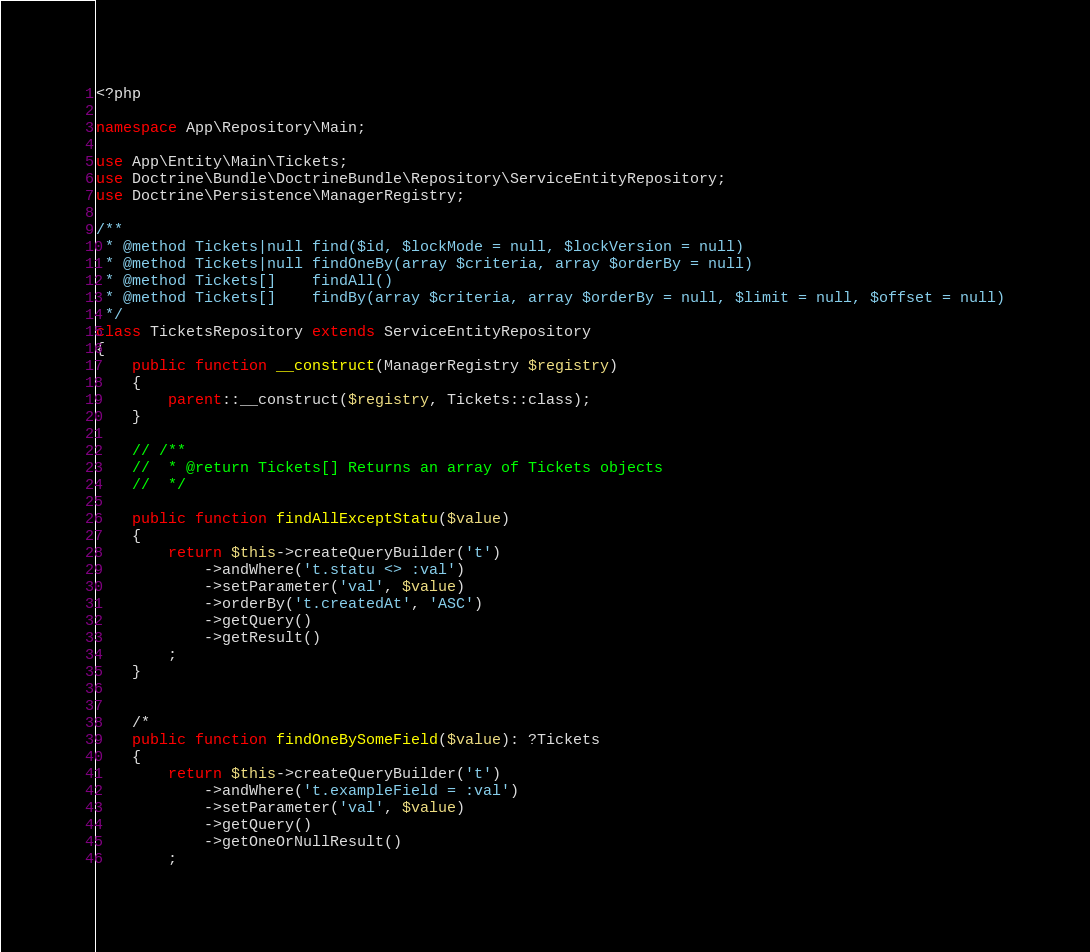Convert code to text. <code><loc_0><loc_0><loc_500><loc_500><_PHP_><?php

namespace App\Repository\Main;

use App\Entity\Main\Tickets;
use Doctrine\Bundle\DoctrineBundle\Repository\ServiceEntityRepository;
use Doctrine\Persistence\ManagerRegistry;

/**
 * @method Tickets|null find($id, $lockMode = null, $lockVersion = null)
 * @method Tickets|null findOneBy(array $criteria, array $orderBy = null)
 * @method Tickets[]    findAll()
 * @method Tickets[]    findBy(array $criteria, array $orderBy = null, $limit = null, $offset = null)
 */
class TicketsRepository extends ServiceEntityRepository
{
    public function __construct(ManagerRegistry $registry)
    {
        parent::__construct($registry, Tickets::class);
    }

    // /**
    //  * @return Tickets[] Returns an array of Tickets objects
    //  */
    
    public function findAllExceptStatu($value)
    {
        return $this->createQueryBuilder('t')
            ->andWhere('t.statu <> :val')
            ->setParameter('val', $value)
            ->orderBy('t.createdAt', 'ASC')
            ->getQuery()
            ->getResult()
        ;
    }
    

    /*
    public function findOneBySomeField($value): ?Tickets
    {
        return $this->createQueryBuilder('t')
            ->andWhere('t.exampleField = :val')
            ->setParameter('val', $value)
            ->getQuery()
            ->getOneOrNullResult()
        ;</code> 